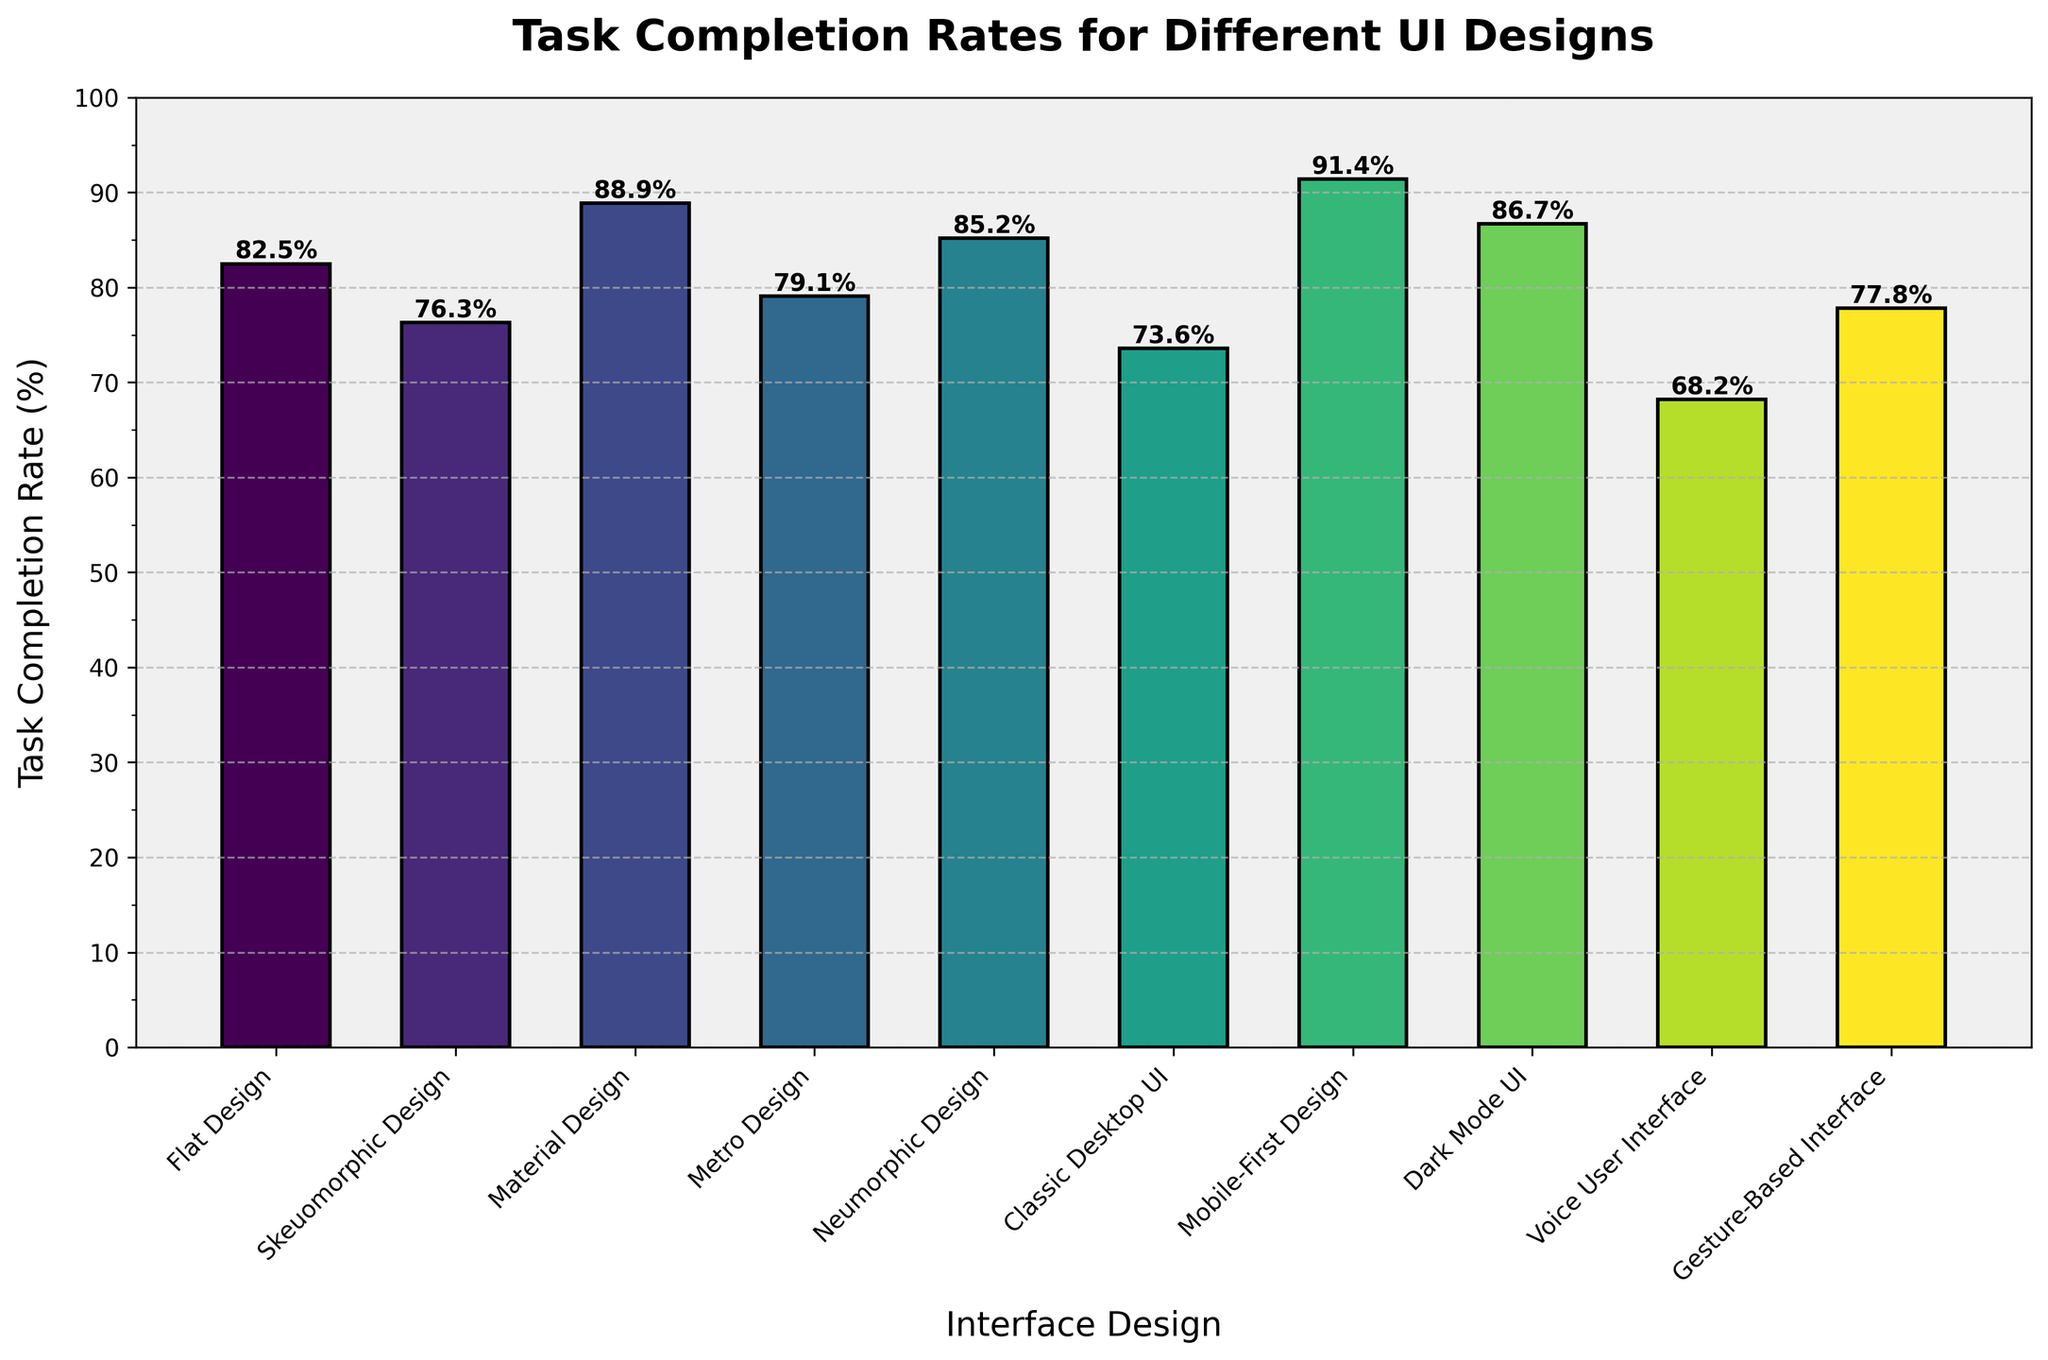Which interface design has the highest task completion rate? The bar representing the Mobile-First Design is the tallest, indicating it has the highest task completion rate among all designs.
Answer: Mobile-First Design What is the difference in task completion rate between the highest and lowest performing designs? Mobile-First Design has the highest completion rate at 91.4%, and Voice User Interface has the lowest at 68.2%. The difference is 91.4% - 68.2% = 23.2%.
Answer: 23.2% Which design has a higher task completion rate: Skeuomorphic Design or Metro Design? Comparing the heights of the bars, Skeuomorphic Design has a completion rate of 76.3% while Metro Design has a rate of 79.1%. Metro Design has a higher rate.
Answer: Metro Design What is the average task completion rate of all the designs? Sum all the task completion rates: 82.5 + 76.3 + 88.9 + 79.1 + 85.2 + 73.6 + 91.4 + 86.7 + 68.2 + 77.8 = 809.7. Divide by the number of designs: 809.7 / 10 = 80.97%.
Answer: 80.97% Are there more designs with task completion rates above 80% or below 80%? Count the designs above 80%: Flat Design, Material Design, Neumorphic Design, Mobile-First Design, Dark Mode UI (5 designs). Count the designs below 80%: Skeuomorphic Design, Metro Design, Classic Desktop UI, Voice User Interface, Gesture-Based Interface (5 designs). It’s equal.
Answer: Equal Which designs have a task completion rate between 70% and 80%? Identify the bars that are between 70% and 80% in height: Skeuomorphic Design (76.3%), Metro Design (79.1%), Classic Desktop UI (73.6%), Gesture-Based Interface (77.8%).
Answer: Skeuomorphic Design, Metro Design, Classic Desktop UI, Gesture-Based Interface How does the task completion rate of Neumorphic Design compare to Dark Mode UI? By comparing the bars, Neumorphic Design has a completion rate of 85.2%, while Dark Mode UI has 86.7%. Dark Mode UI has a slightly higher rate.
Answer: Dark Mode UI 